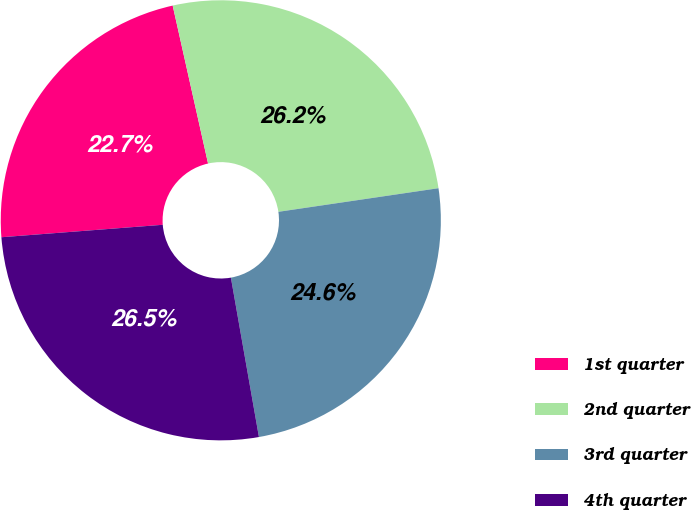Convert chart to OTSL. <chart><loc_0><loc_0><loc_500><loc_500><pie_chart><fcel>1st quarter<fcel>2nd quarter<fcel>3rd quarter<fcel>4th quarter<nl><fcel>22.72%<fcel>26.18%<fcel>24.56%<fcel>26.55%<nl></chart> 